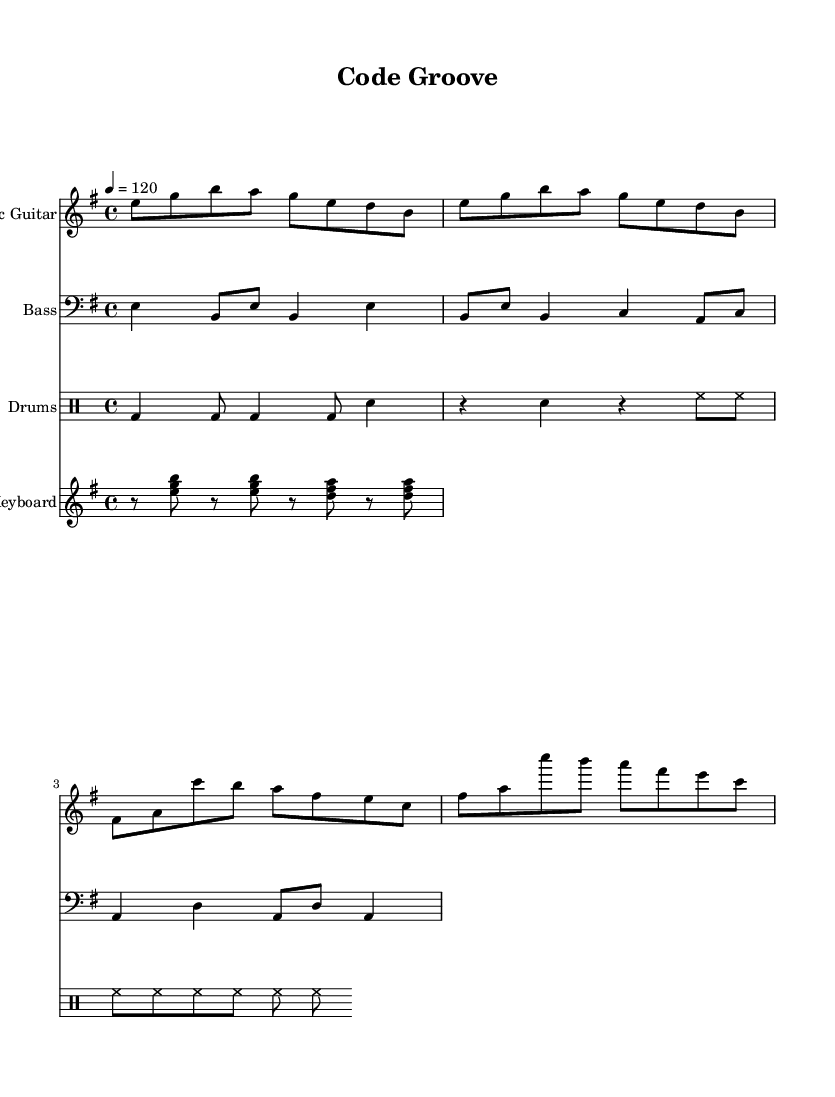What is the key signature of this music? The key signature is E minor, which contains one sharp (F sharp). It can be deduced from the first part of the music sheet where the key signature is indicated next to the clef.
Answer: E minor What is the time signature of this music? The time signature is 4/4, as specified in the beginning of the music sheet where it indicates how many beats are in a measure and what note value gets the beat.
Answer: 4/4 What is the tempo marking of this piece? The tempo marking is 120 beats per minute, as indicated at the beginning of the sheet. It indicates the speed of the piece.
Answer: 120 How many measures are there in the electric guitar part? By counting the segments separated by the vertical lines, we can see there are 8 measures in the electric guitar part. Each measure is demarcated clearly in the notation.
Answer: 8 Which instrument has the clef "bass"? The bass guitar part uses the bass clef, which indicates that the notes should be played in a lower pitch range. This is visually evident in the staff where the clef symbol is placed at the beginning.
Answer: Bass What rhythmic pattern does the drum part predominantly use? The drum part predominantly utilizes a pattern of bass and snare hits alternating with hi-hat cymbals, creating a standard funk groove. This is recognizable from the drummode notation where different drums are notated explicitly.
Answer: Alternating bass and snare with hi-hat What type of musical style does this composition represent? This composition represents an energetic funk-rock fusion style, which is characterized by the rhythm, grooves, and instrumental combinations indicated in the sheet music. This is shown through the various sections represented and the overall upbeat tempo.
Answer: Funk-rock fusion 